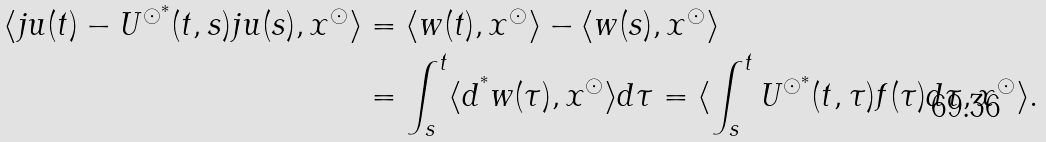<formula> <loc_0><loc_0><loc_500><loc_500>\langle j u ( t ) - U ^ { \odot ^ { * } } ( t , s ) j u ( s ) , x ^ { \odot } \rangle & = \langle w ( t ) , x ^ { \odot } \rangle - \langle w ( s ) , x ^ { \odot } \rangle \\ & = \int _ { s } ^ { t } \langle d ^ { ^ { * } } w ( \tau ) , x ^ { \odot } \rangle d \tau = \langle \int _ { s } ^ { t } U ^ { \odot ^ { * } } ( t , \tau ) f ( \tau ) d \tau , x ^ { \odot } \rangle .</formula> 